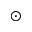<formula> <loc_0><loc_0><loc_500><loc_500>_ { \odot }</formula> 